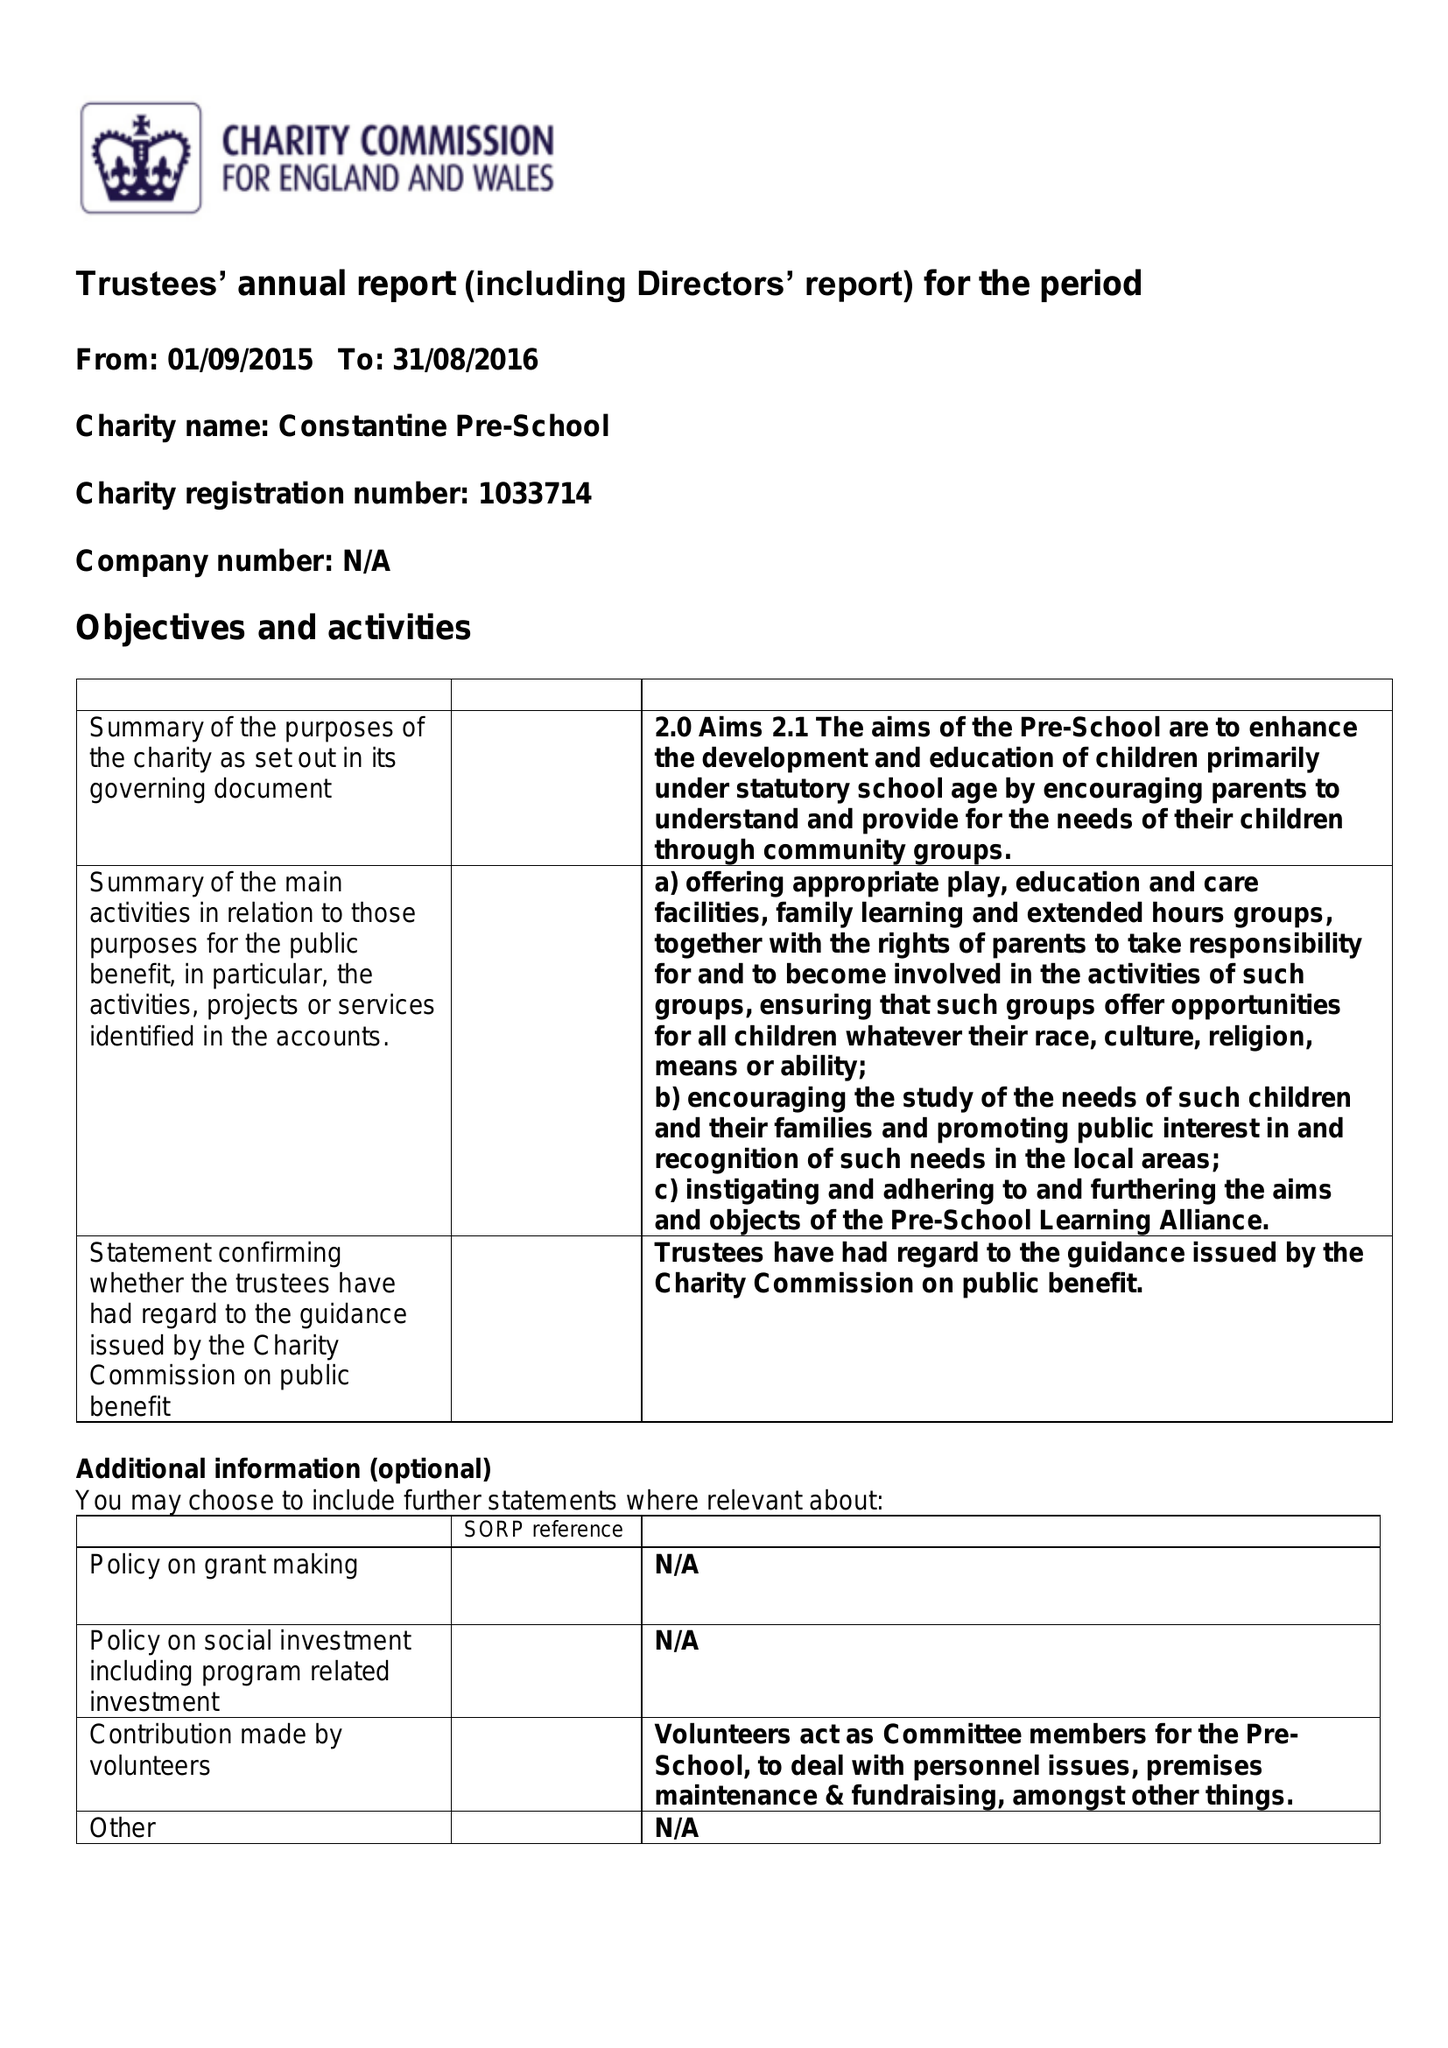What is the value for the address__post_town?
Answer the question using a single word or phrase. FALMOUTH 